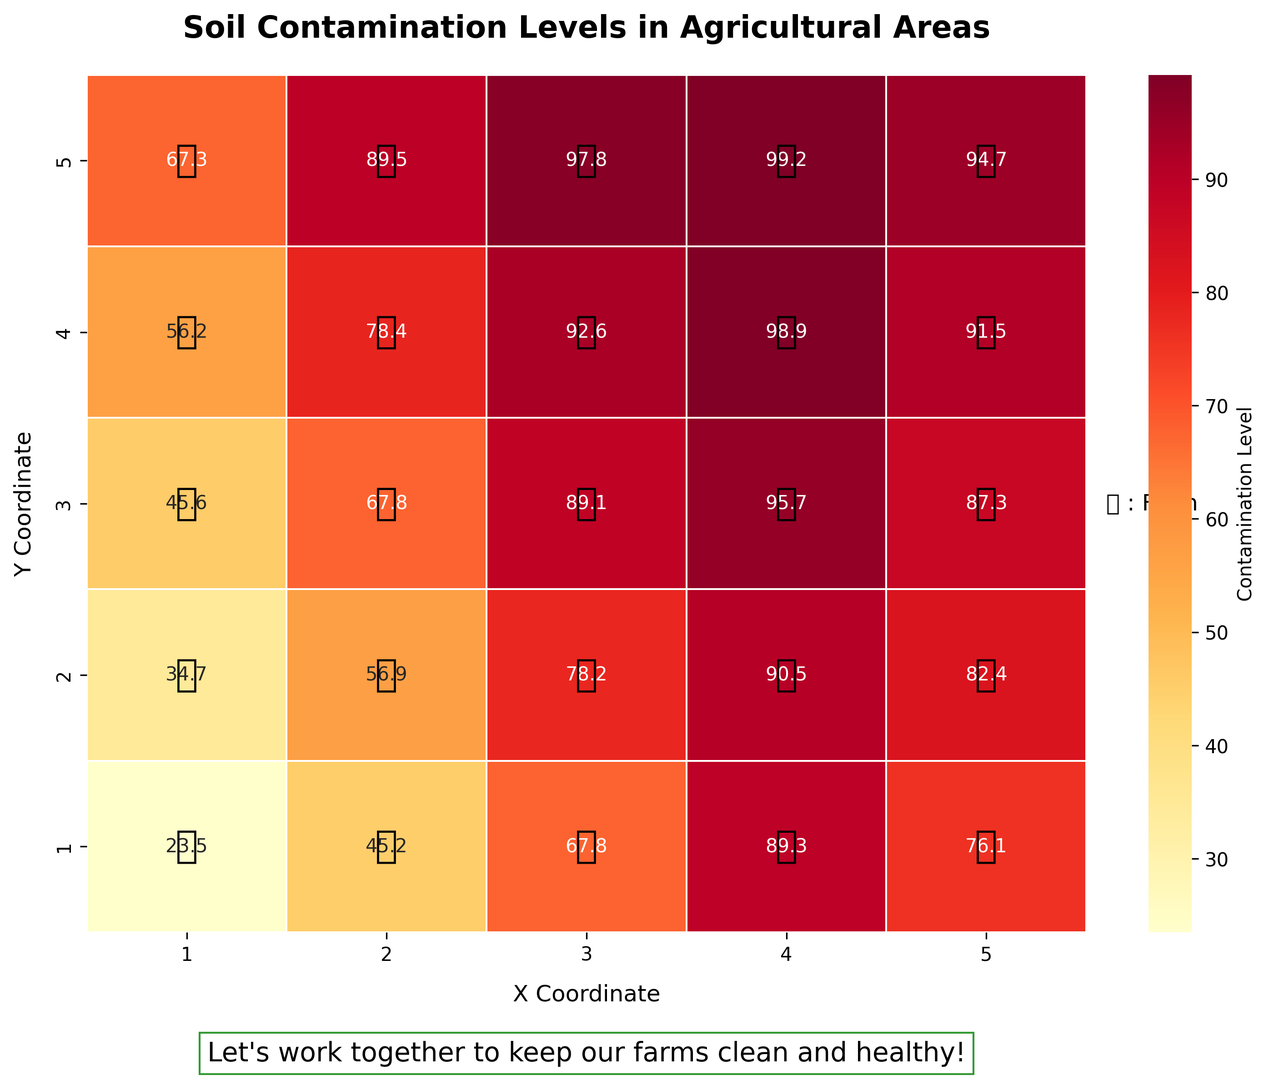What is the contamination level at Farm X? To find the contamination level at Farm X, locate the coordinates (4, 5) on the heatmap. The value at this coordinate is clearly visible on the heatmap.
Answer: 99.2 Which farm has the highest contamination level? Scan the heatmap for the highest value among all the displayed data points. The highest observed value is 99.2 at Farm X.
Answer: Farm X What is the average contamination level at the farms along the Y-coordinate 3? First, identify the farms along the Y-coordinate 3: Farms K, L, M, N, and O. Calculate the average by summing the contamination levels (45.6, 67.8, 89.1, 95.7, 87.3) and dividing by the number of farms. The sum is 385.5, and there are 5 farms, so the average is 385.5 / 5.
Answer: 77.1 How does the contamination level at Farm G (2, 2) compare to that at Farm B (2, 1)? Locate both Farm G (2, 2) and Farm B (2, 1) on the heatmap. Farm G has a contamination level of 56.9, while Farm B has 45.2. Comparing the two, 56.9 is higher than 45.2.
Answer: Higher Which coordinate has the lowest contamination level and what is the value? Scan the heatmap for the lowest value among all data points. The lowest observed value is 23.5 at Farm A (1, 1).
Answer: (1, 1) with 23.5 Determine the average contamination level for the farms located on X-coordinate 4. Identify the farms along X-coordinate 4: Farms D, I, N, S, and X. Calculate the average by summing the contamination levels (89.3, 90.5, 95.7, 98.9, 99.2) and dividing by the number of farms. The sum is 473.6, and there are 5 farms, so the average is 473.6 / 5.
Answer: 94.7 